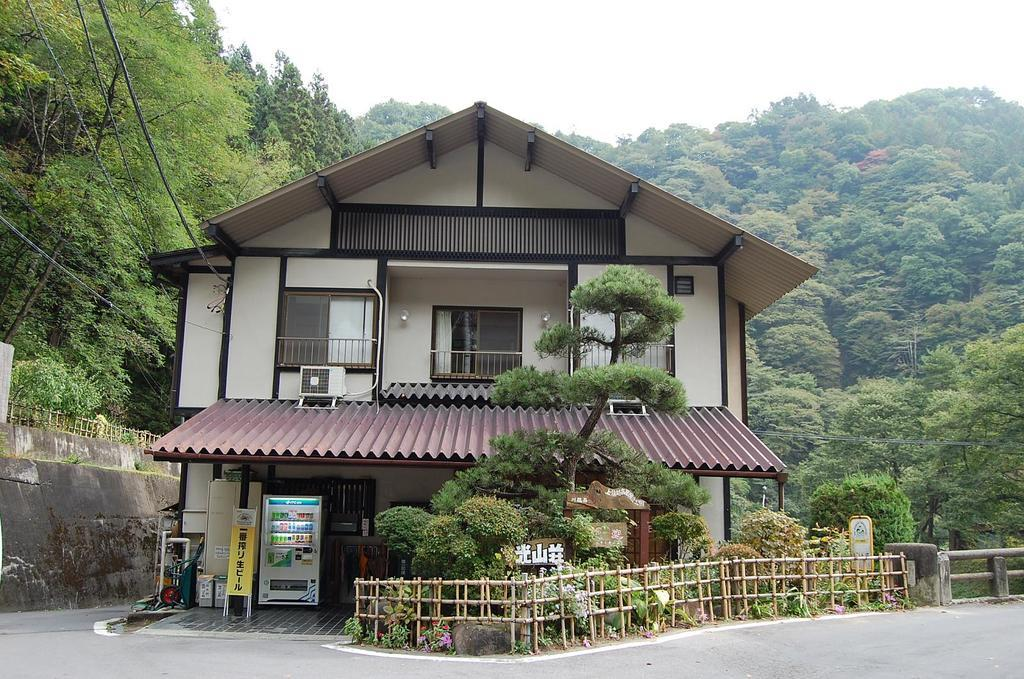What type of surface can be seen in the image? The image contains a road. What kind of equipment is present in the image? There is a machine in the image. What structures are visible in the image? Fences and walls are present in the image. What is attached to the wall in the image? There is a poster on the wall. What type of vegetation is present in the image? Trees are present in the image. What type of building is visible in the image? The image includes a building with windows. What other objects can be seen in the image? There are some objects in the image. What is visible in the background of the image? The sky is visible in the background of the image. Can you tell me how the stranger is learning from the side in the image? There is no stranger present in the image, and therefore no learning or side-related activities can be observed. 